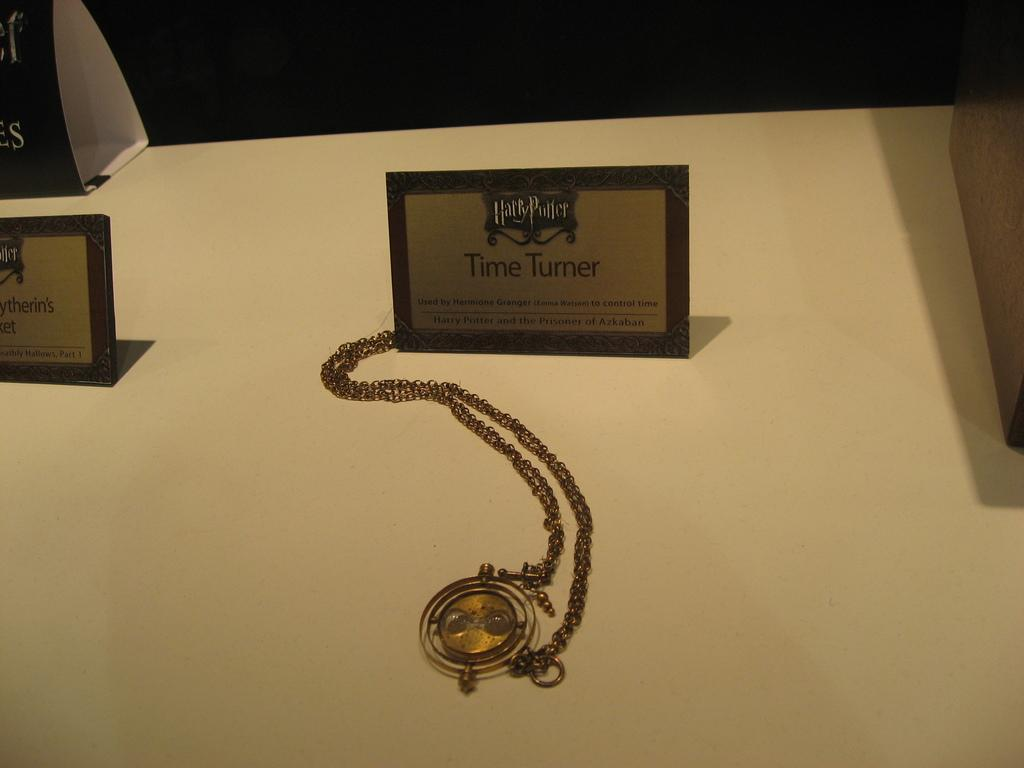<image>
Provide a brief description of the given image. The golden Time Turner used by Hermione in the Harry Potter movies is on display. 